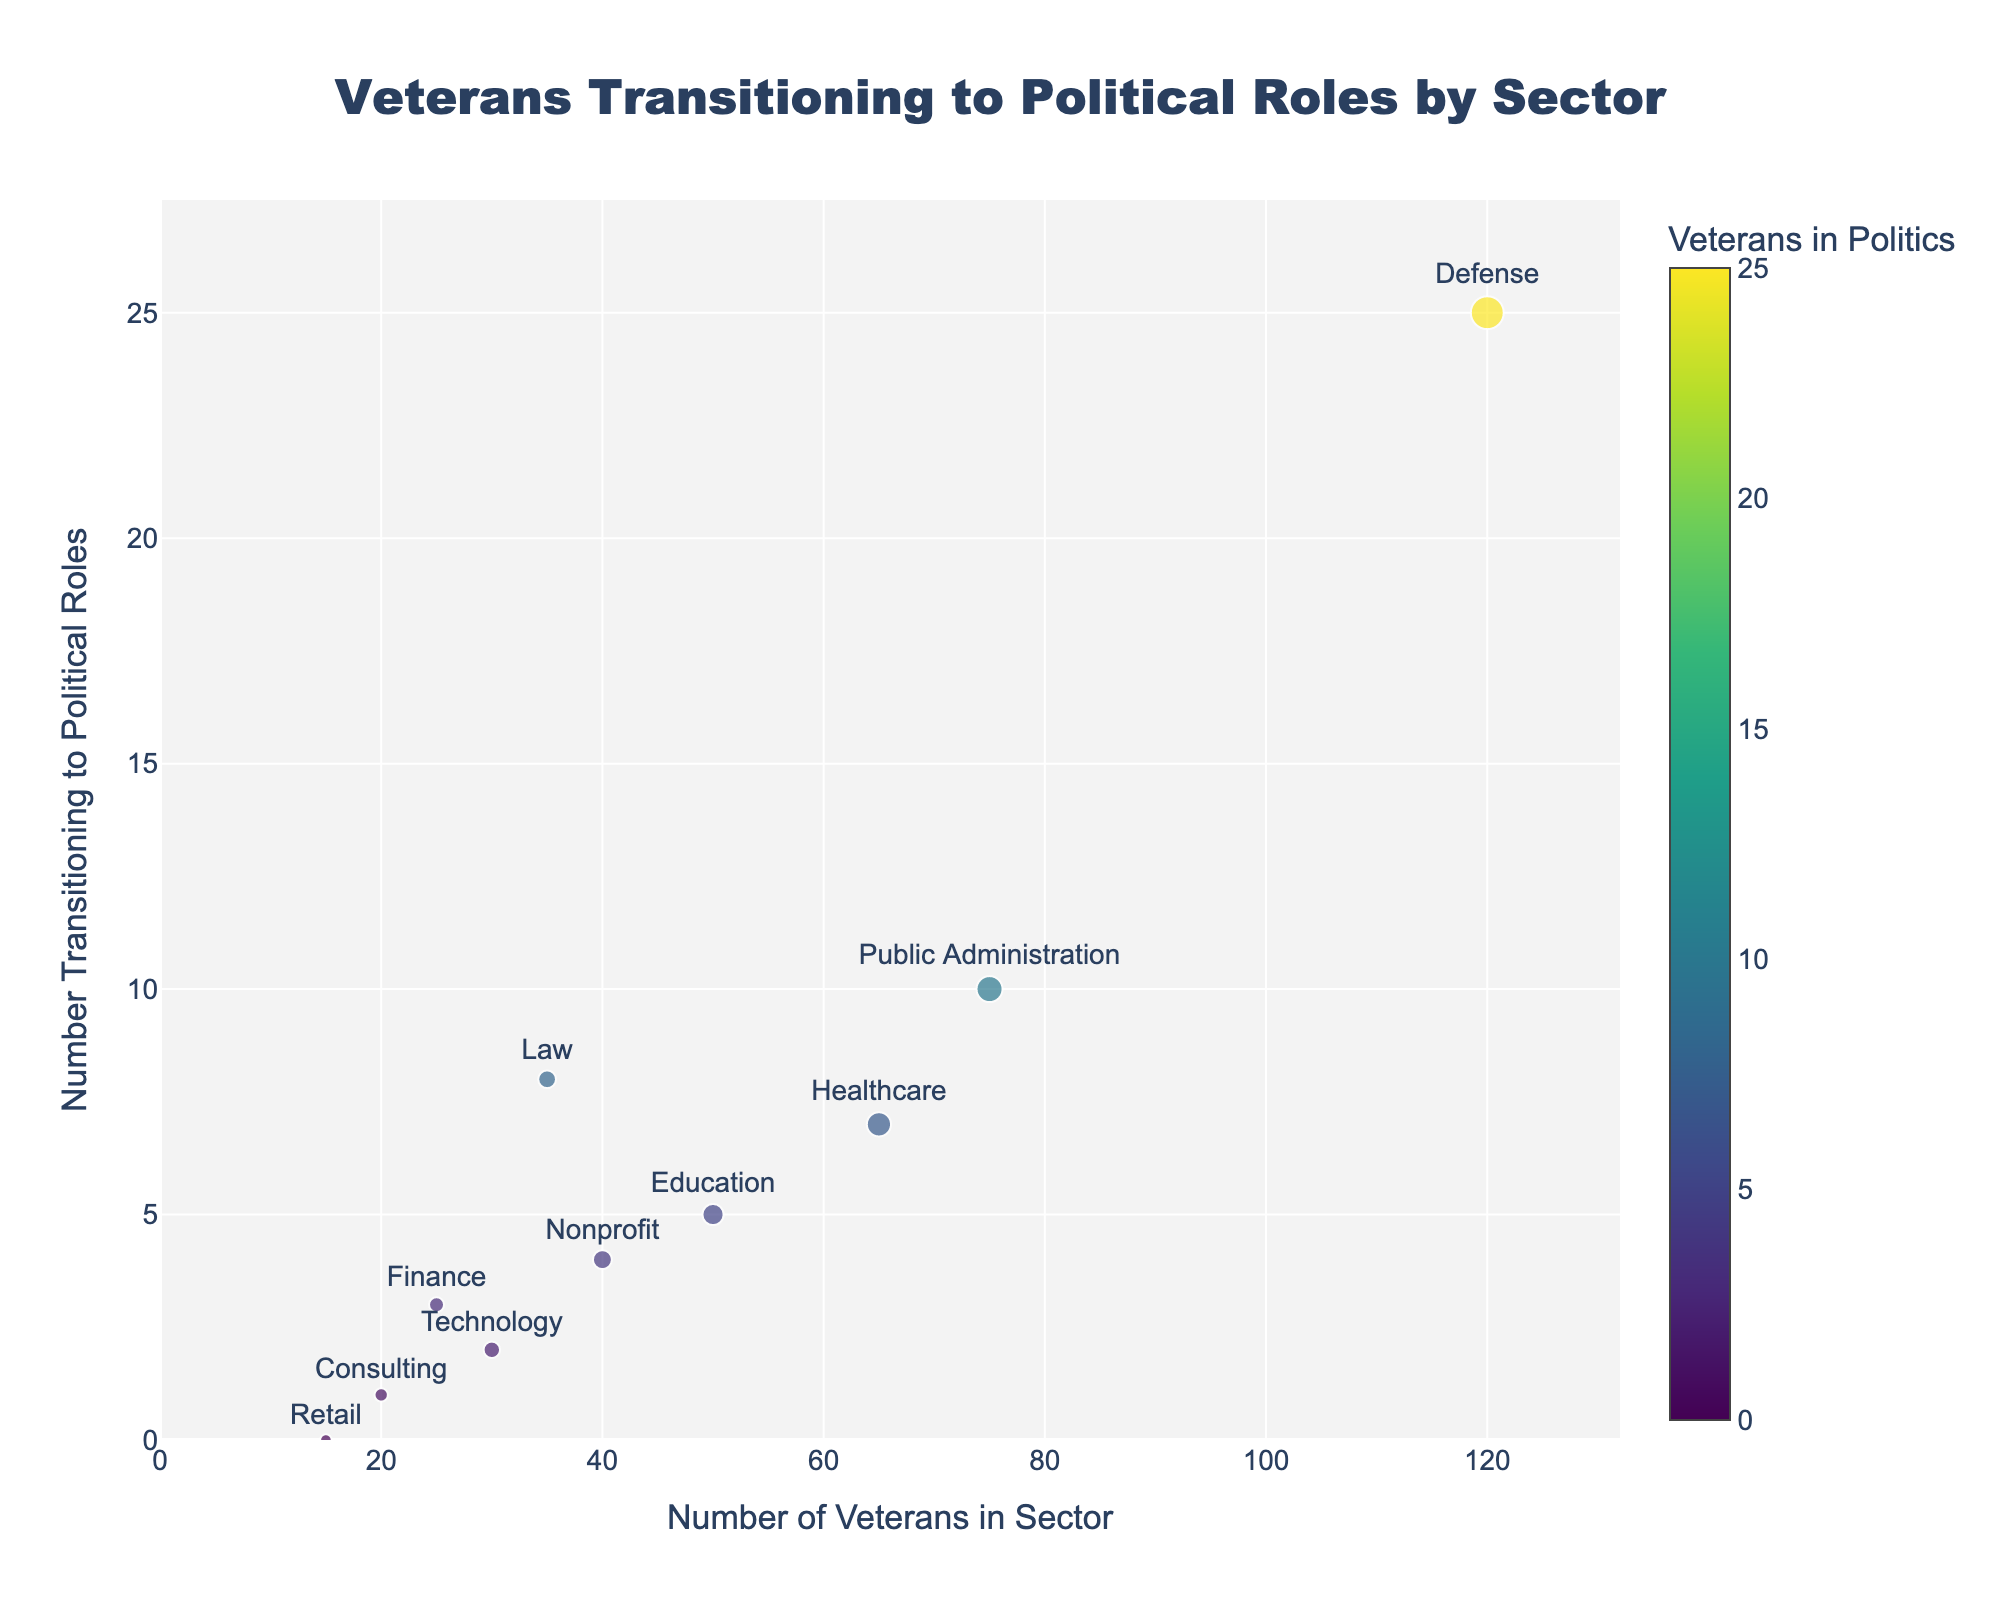What is the title of the figure? The title of the figure is usually located at the top of the chart. In this case, it reads: "Veterans Transitioning to Political Roles by Sector".
Answer: Veterans Transitioning to Political Roles by Sector Which sector has the highest number of veterans transitioning to political roles? By analyzing the y-axis, we can see which sector has the highest value. The 'Defense' sector has the highest number transitioning to political roles, with 25.
Answer: Defense How many sectors have more than 5 veterans transitioning to political roles? By inspecting the y-axis values, the sectors with more than 5 veterans transitioning are 'Defense', 'Healthcare', 'Law', and 'Public Administration'. That makes 4 sectors.
Answer: 4 What is the size of the marker for the 'Education' sector? The size of the markers is proportional to the square root of the number of veterans in the sector. For 'Education', there are 50 veterans. Therefore, the marker size is √50 * 1.5 ≈ 10.61.
Answer: Approximately 10.61 What color scale is used for the markers in the plot? The figure uses the Viridis colorscale for the markers, with colors representing the number transitioning to political roles.
Answer: Viridis Which sectors have fewer than 20 veterans, and do any of them have veterans transitioning to political roles? The sectors with fewer than 20 veterans are 'Consulting' and 'Retail'. Only 'Consulting' has 1 veteran transitioning to a political role; 'Retail' has 0.
Answer: Consulting has 1, Retail has 0 Does 'Healthcare' or 'Public Administration' have more veterans in the sector? By comparing their positions on the x-axis, 'Public Administration' has 75 veterans, whereas 'Healthcare' has 65. Hence, 'Public Administration' has more.
Answer: Public Administration Which sector shows the least number of veterans transitioning into political roles, and how many? By checking the y-axis, 'Retail' shows the least number with 0 veterans transitioning into political roles.
Answer: Retail with 0 What is the average number of veterans transitioning to political roles across all sectors? To find the average, sum up all transitioning veterans: 5+7+25+2+4+8+3+10+1+0 = 65. There are 10 sectors, so the average is 65/10 = 6.5.
Answer: 6.5 What is the total number of veterans across all sectors? Sum the number of veterans from all sectors: 50+65+120+30+40+35+25+75+20+15 = 475.
Answer: 475 